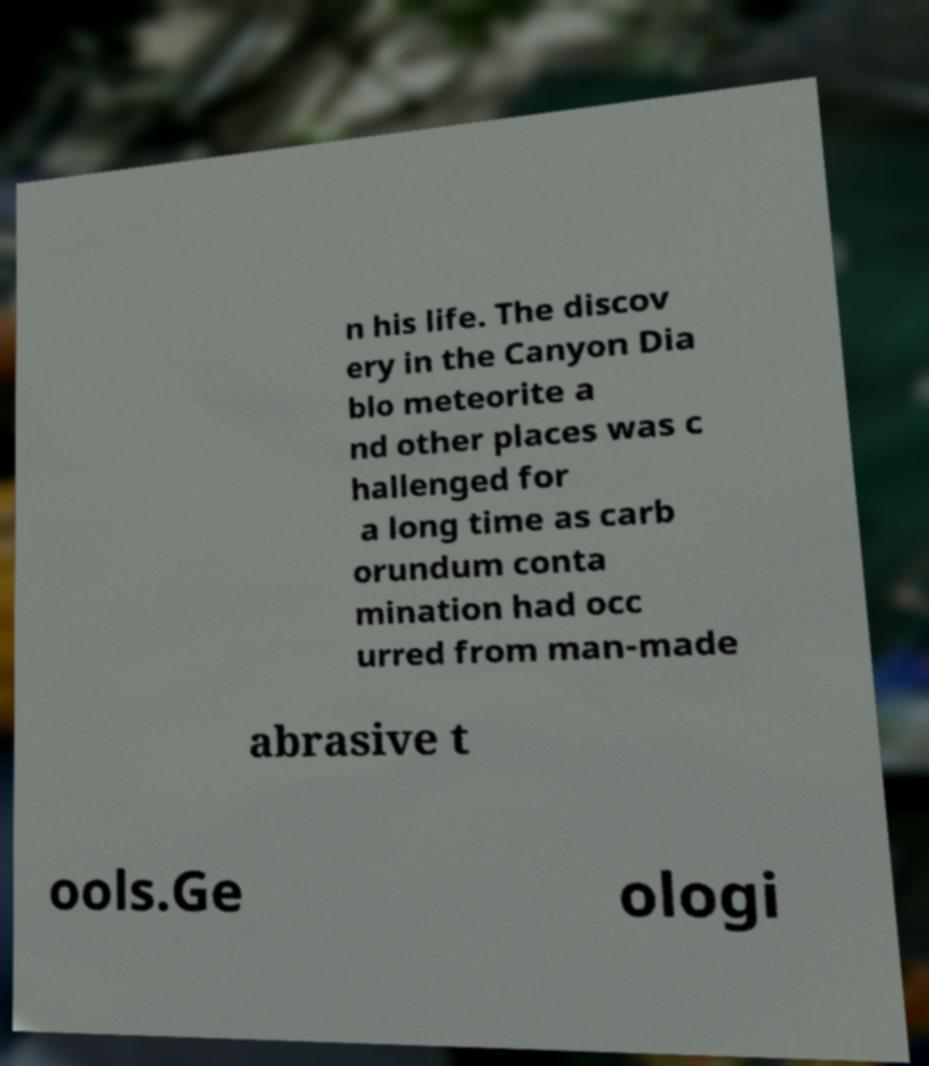Could you assist in decoding the text presented in this image and type it out clearly? n his life. The discov ery in the Canyon Dia blo meteorite a nd other places was c hallenged for a long time as carb orundum conta mination had occ urred from man-made abrasive t ools.Ge ologi 